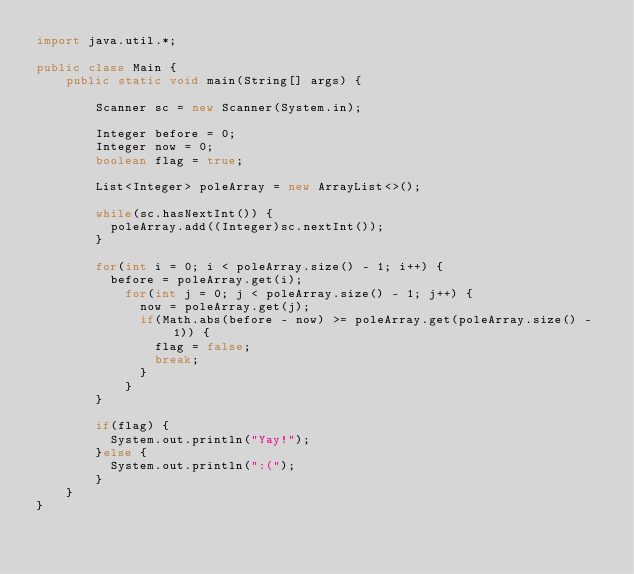<code> <loc_0><loc_0><loc_500><loc_500><_Java_>import java.util.*;

public class Main {
    public static void main(String[] args) {

        Scanner sc = new Scanner(System.in);
        
        Integer before = 0;
        Integer now = 0;
        boolean flag = true;
        
        List<Integer> poleArray = new ArrayList<>();
        
        while(sc.hasNextInt()) {
        	poleArray.add((Integer)sc.nextInt());
        }
        
        for(int i = 0; i < poleArray.size() - 1; i++) {
        	before = poleArray.get(i);
        		for(int j = 0; j < poleArray.size() - 1; j++) {
        			now = poleArray.get(j);  
		        	if(Math.abs(before - now) >= poleArray.get(poleArray.size() - 1)) {
		        		flag = false;
		        		break;
		        	}
        		}
        }
        
        if(flag) {
        	System.out.println("Yay!");
        }else {
        	System.out.println(":(");
        }
    }
}</code> 